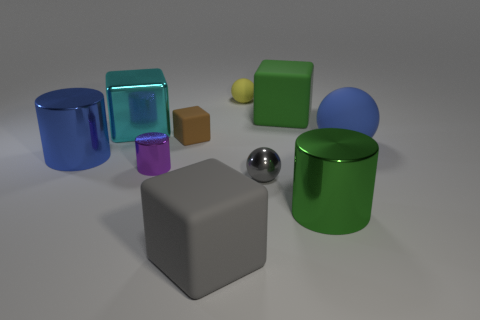The big green rubber thing left of the green object on the right side of the big rubber object that is behind the large cyan object is what shape?
Provide a short and direct response. Cube. There is a matte cube in front of the big blue cylinder; is it the same color as the big matte cube behind the cyan metallic cube?
Your response must be concise. No. What is the shape of the object that is the same color as the large rubber sphere?
Your response must be concise. Cylinder. How many matte objects are brown cubes or spheres?
Offer a very short reply. 3. There is a big metal object to the right of the matte block that is in front of the big metal cylinder to the right of the yellow matte thing; what color is it?
Provide a short and direct response. Green. There is another matte object that is the same shape as the yellow matte object; what is its color?
Provide a succinct answer. Blue. Are there any other things that have the same color as the tiny shiny ball?
Your response must be concise. Yes. What size is the brown block?
Your answer should be compact. Small. Are there any tiny brown matte things that have the same shape as the tiny purple object?
Offer a terse response. No. What number of things are either large cyan shiny things or small things that are in front of the large green block?
Your answer should be compact. 4. 